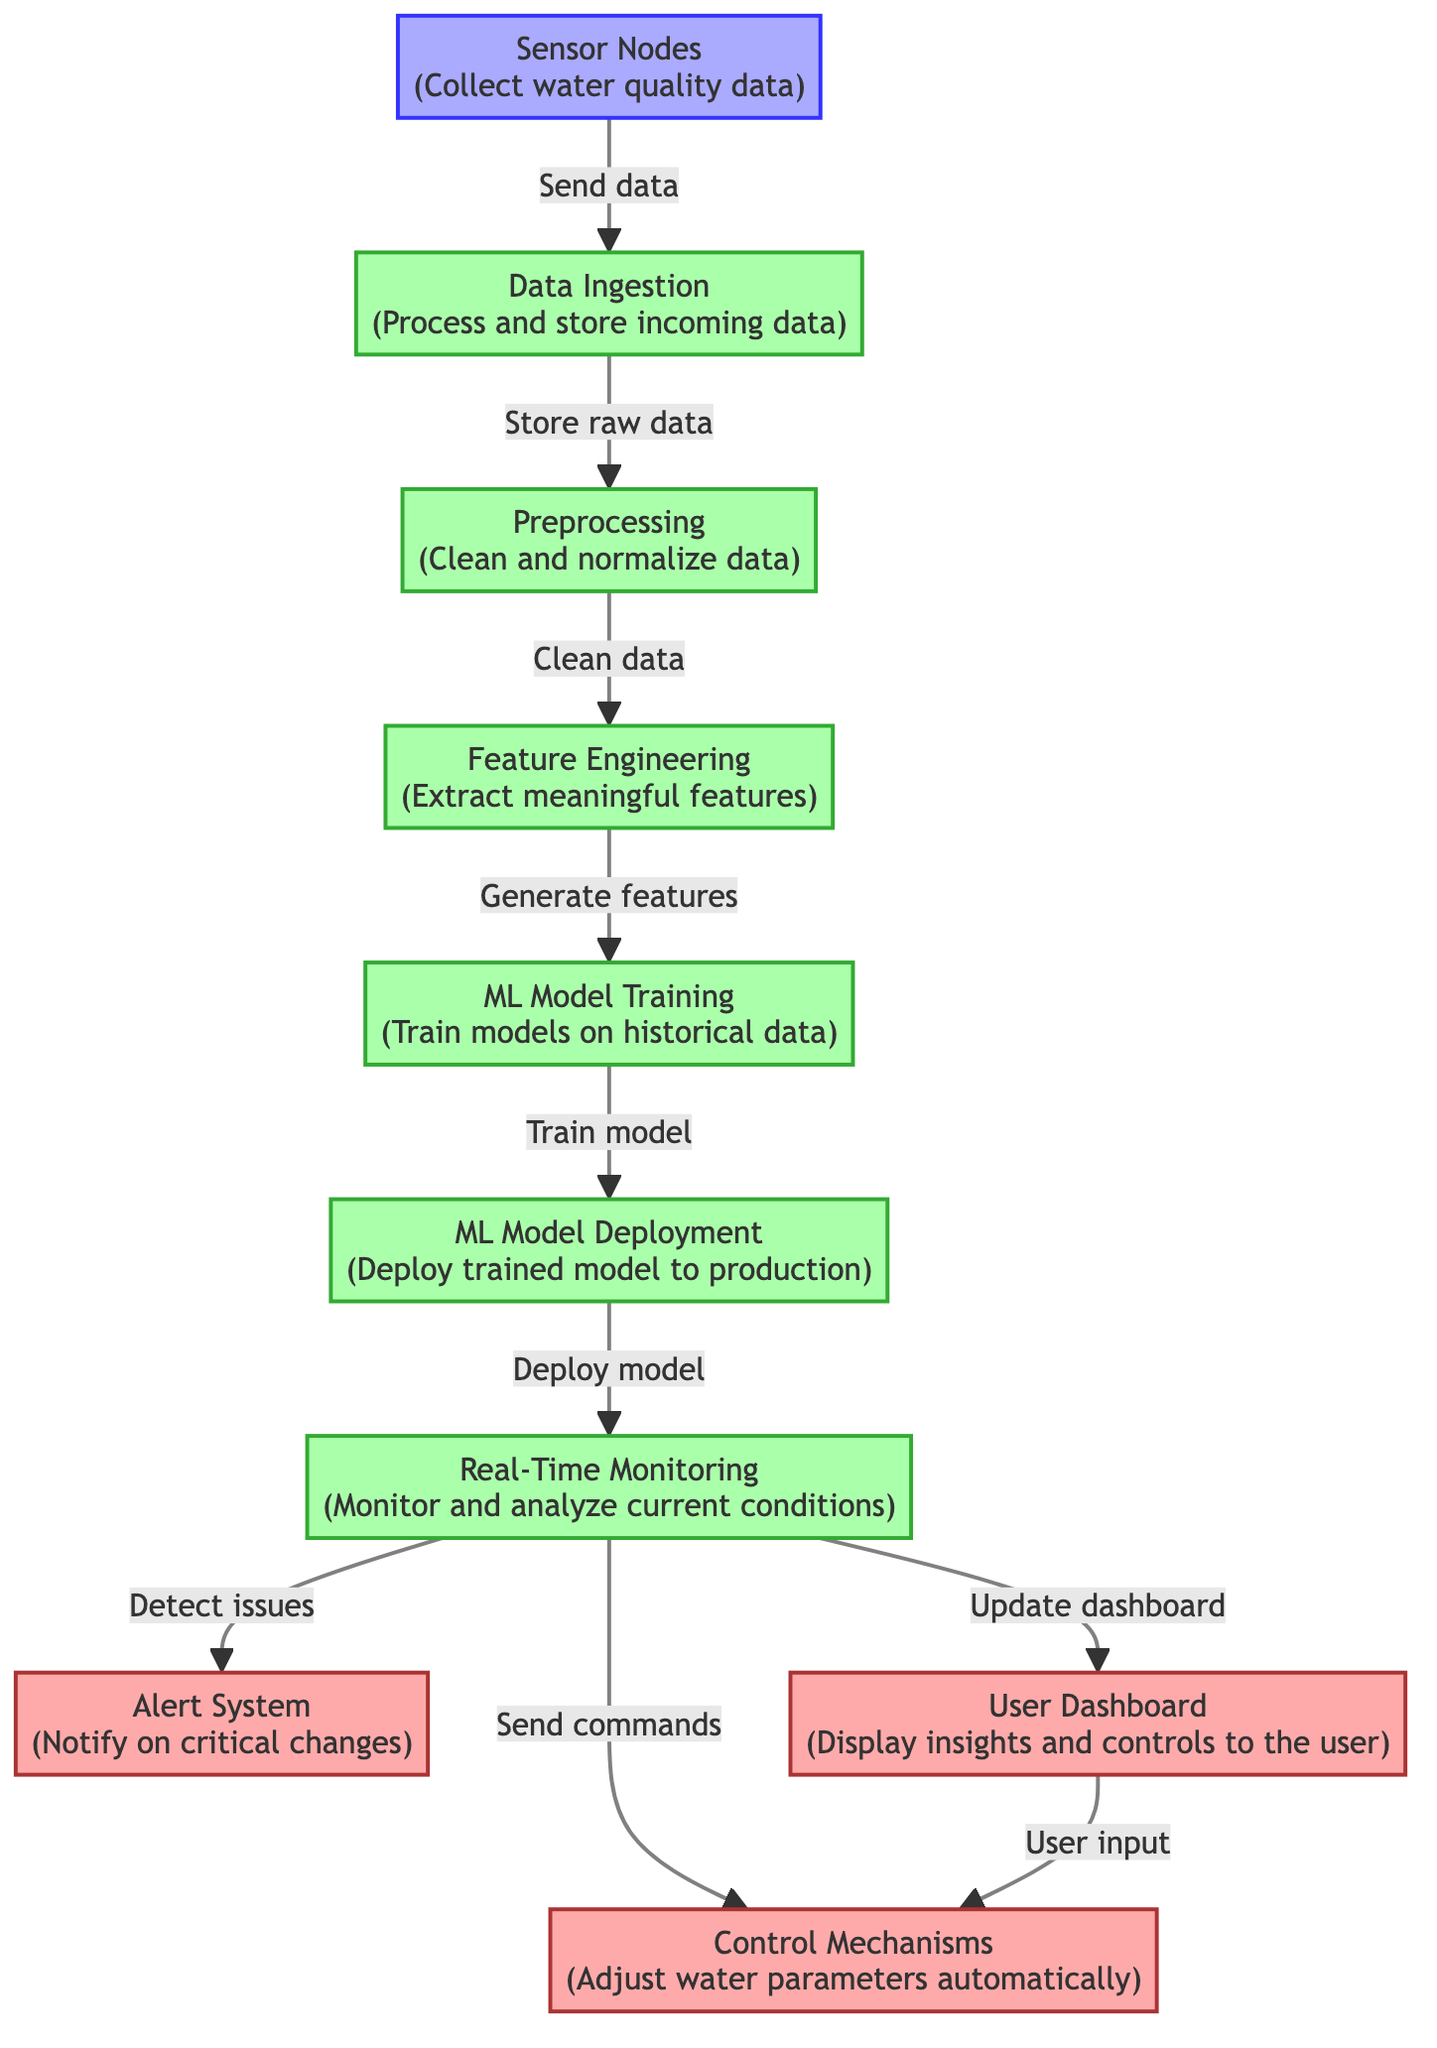What is the first step in the process? The first step, as indicated in the diagram, is "Sensor Nodes," which collect water quality data.
Answer: Sensor Nodes How many outputs are shown in the diagram? There are three outputs labeled: "Alert System," "Control Mechanisms," and "User Dashboard." Counting these gives us three outputs.
Answer: Three Which process comes directly after "Data Ingestion"? The immediate next process after "Data Ingestion" is "Preprocessing," which prepares the data for further analysis.
Answer: Preprocessing What is the purpose of the "Alert System"? The "Alert System" serves to notify users of critical changes in the aquatic environment.
Answer: Notify on critical changes How does the "Real-Time Monitoring" process interact with the "User Dashboard"? "Real-Time Monitoring" updates the "User Dashboard" with the latest insights and controls regarding the aquarium's conditions.
Answer: Update dashboard What is the flow of data from "Preprocessing" to "ML Model Training"? Data flows from "Preprocessing," where it is cleaned, directly to "Feature Engineering," which extracts meaningful features necessary for "ML Model Training."
Answer: Clean data, generate features Which node receives user input? The "User Dashboard" receives user input to facilitate adjustments to the systems controlling the parameters of the aquarium.
Answer: User Dashboard What happens after "ML Model Deployment"? After "ML Model Deployment," the trained model is utilized in the "Real-Time Monitoring" process, where it actively works to monitor and analyze current conditions.
Answer: Real-Time Monitoring What kind of data do "Sensor Nodes" collect? The "Sensor Nodes" collect data on water quality, which is essential for maintaining the aquarium's ecosystem.
Answer: Water quality data 